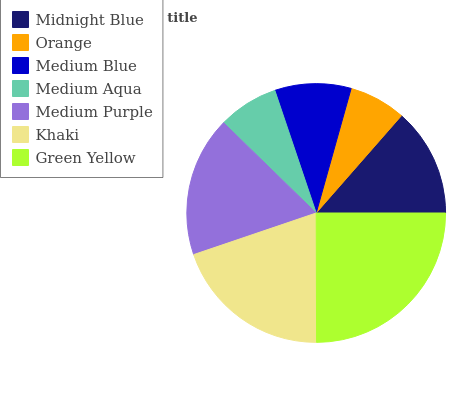Is Orange the minimum?
Answer yes or no. Yes. Is Green Yellow the maximum?
Answer yes or no. Yes. Is Medium Blue the minimum?
Answer yes or no. No. Is Medium Blue the maximum?
Answer yes or no. No. Is Medium Blue greater than Orange?
Answer yes or no. Yes. Is Orange less than Medium Blue?
Answer yes or no. Yes. Is Orange greater than Medium Blue?
Answer yes or no. No. Is Medium Blue less than Orange?
Answer yes or no. No. Is Midnight Blue the high median?
Answer yes or no. Yes. Is Midnight Blue the low median?
Answer yes or no. Yes. Is Khaki the high median?
Answer yes or no. No. Is Green Yellow the low median?
Answer yes or no. No. 